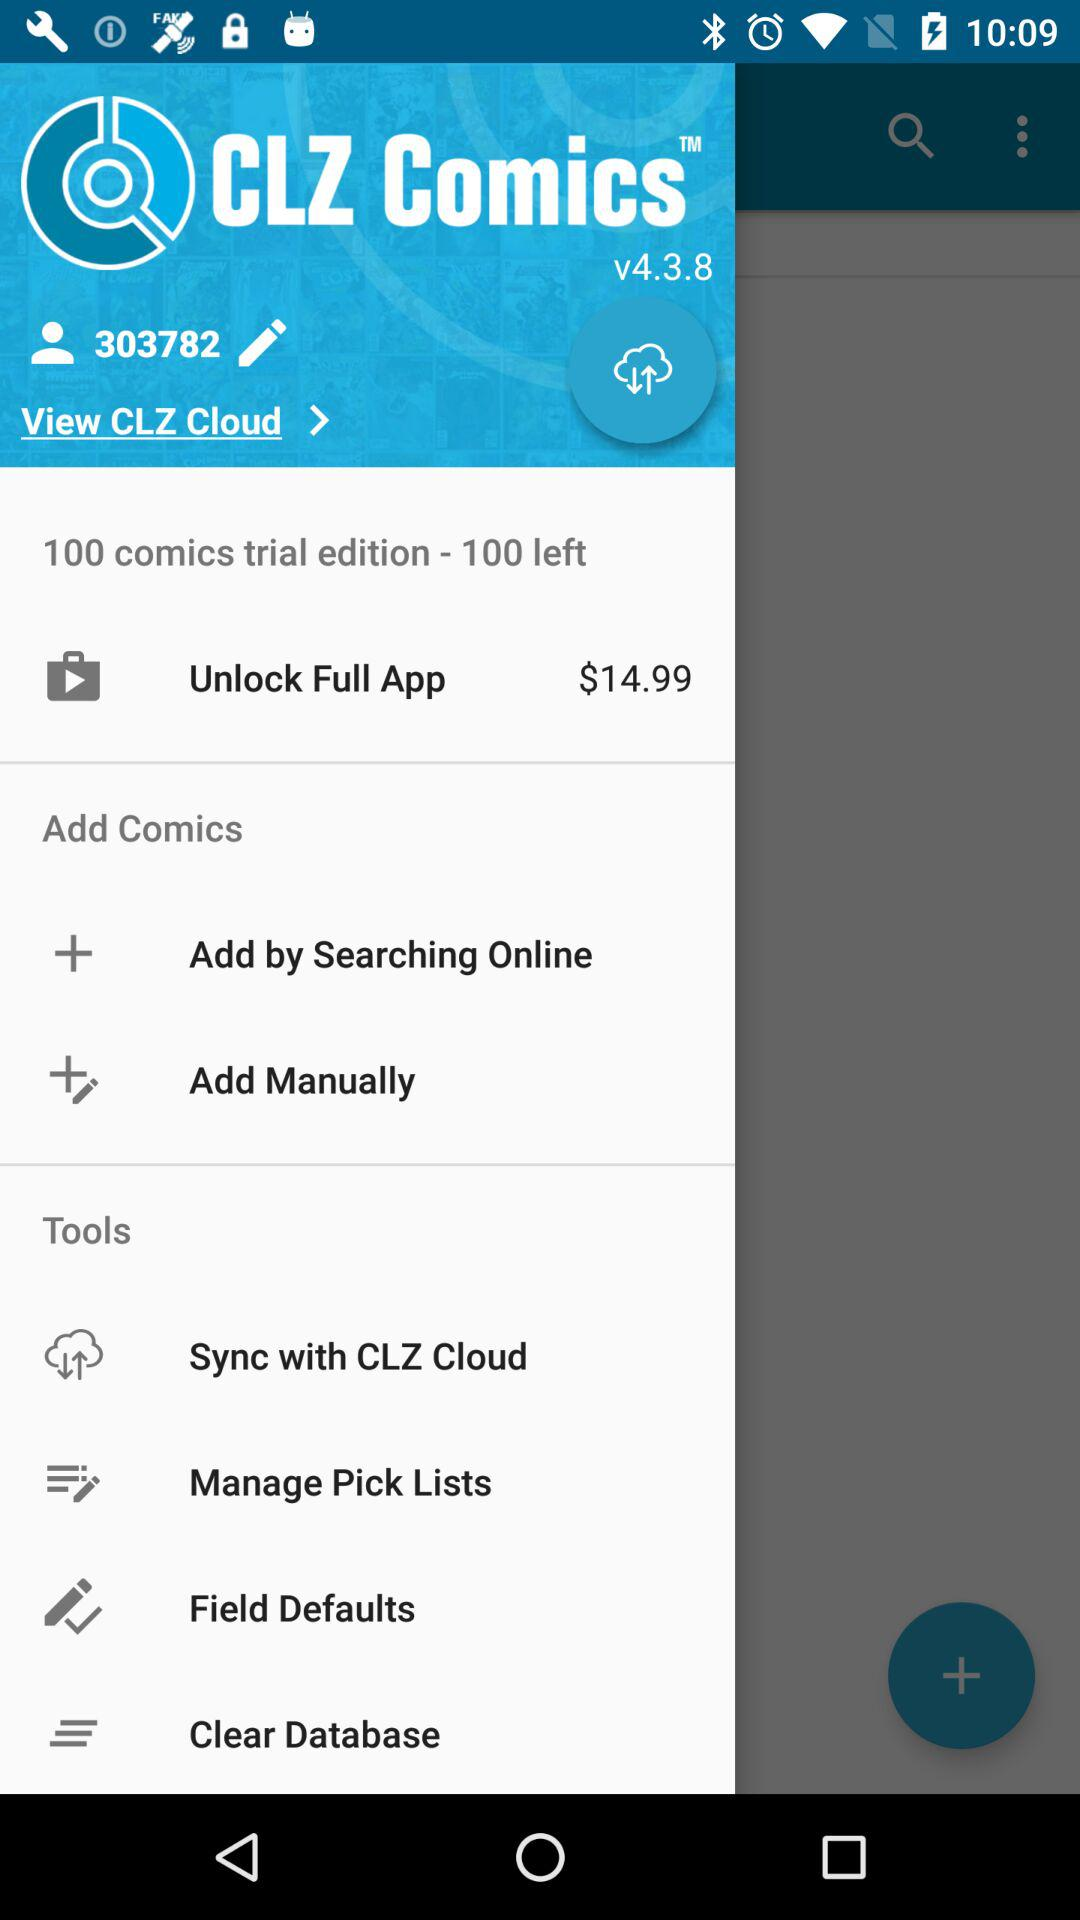What is the application name? The application name is "CLZ Comics". 